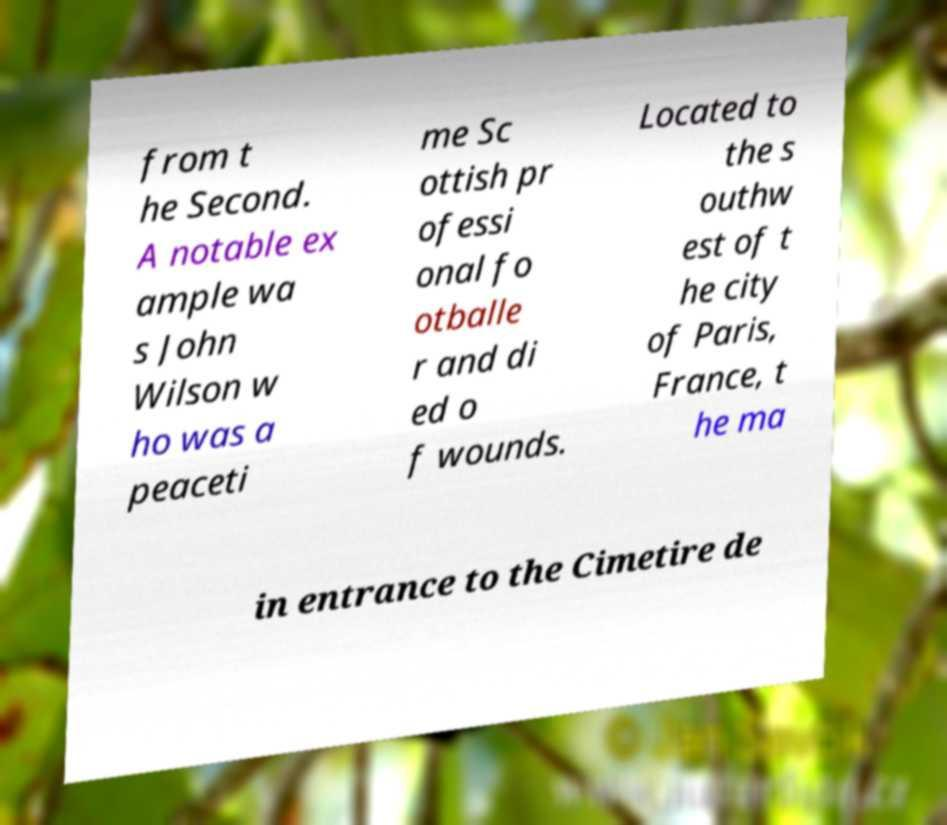Could you assist in decoding the text presented in this image and type it out clearly? from t he Second. A notable ex ample wa s John Wilson w ho was a peaceti me Sc ottish pr ofessi onal fo otballe r and di ed o f wounds. Located to the s outhw est of t he city of Paris, France, t he ma in entrance to the Cimetire de 